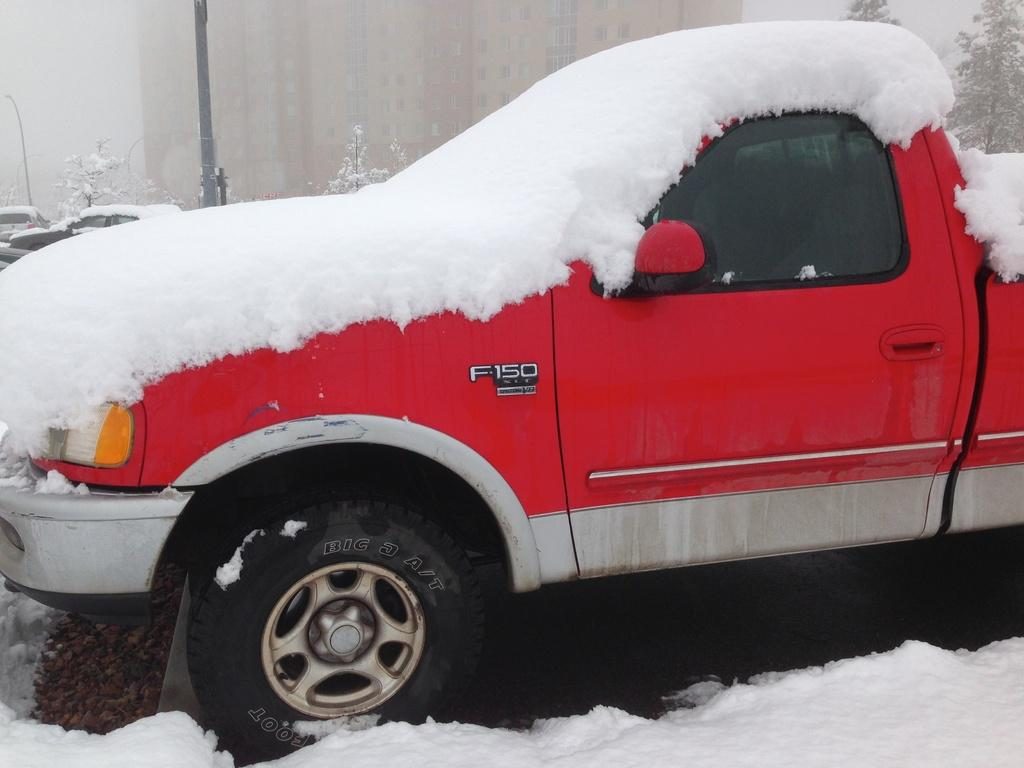<image>
Present a compact description of the photo's key features. A red, F-150 truck has snow all over it. 